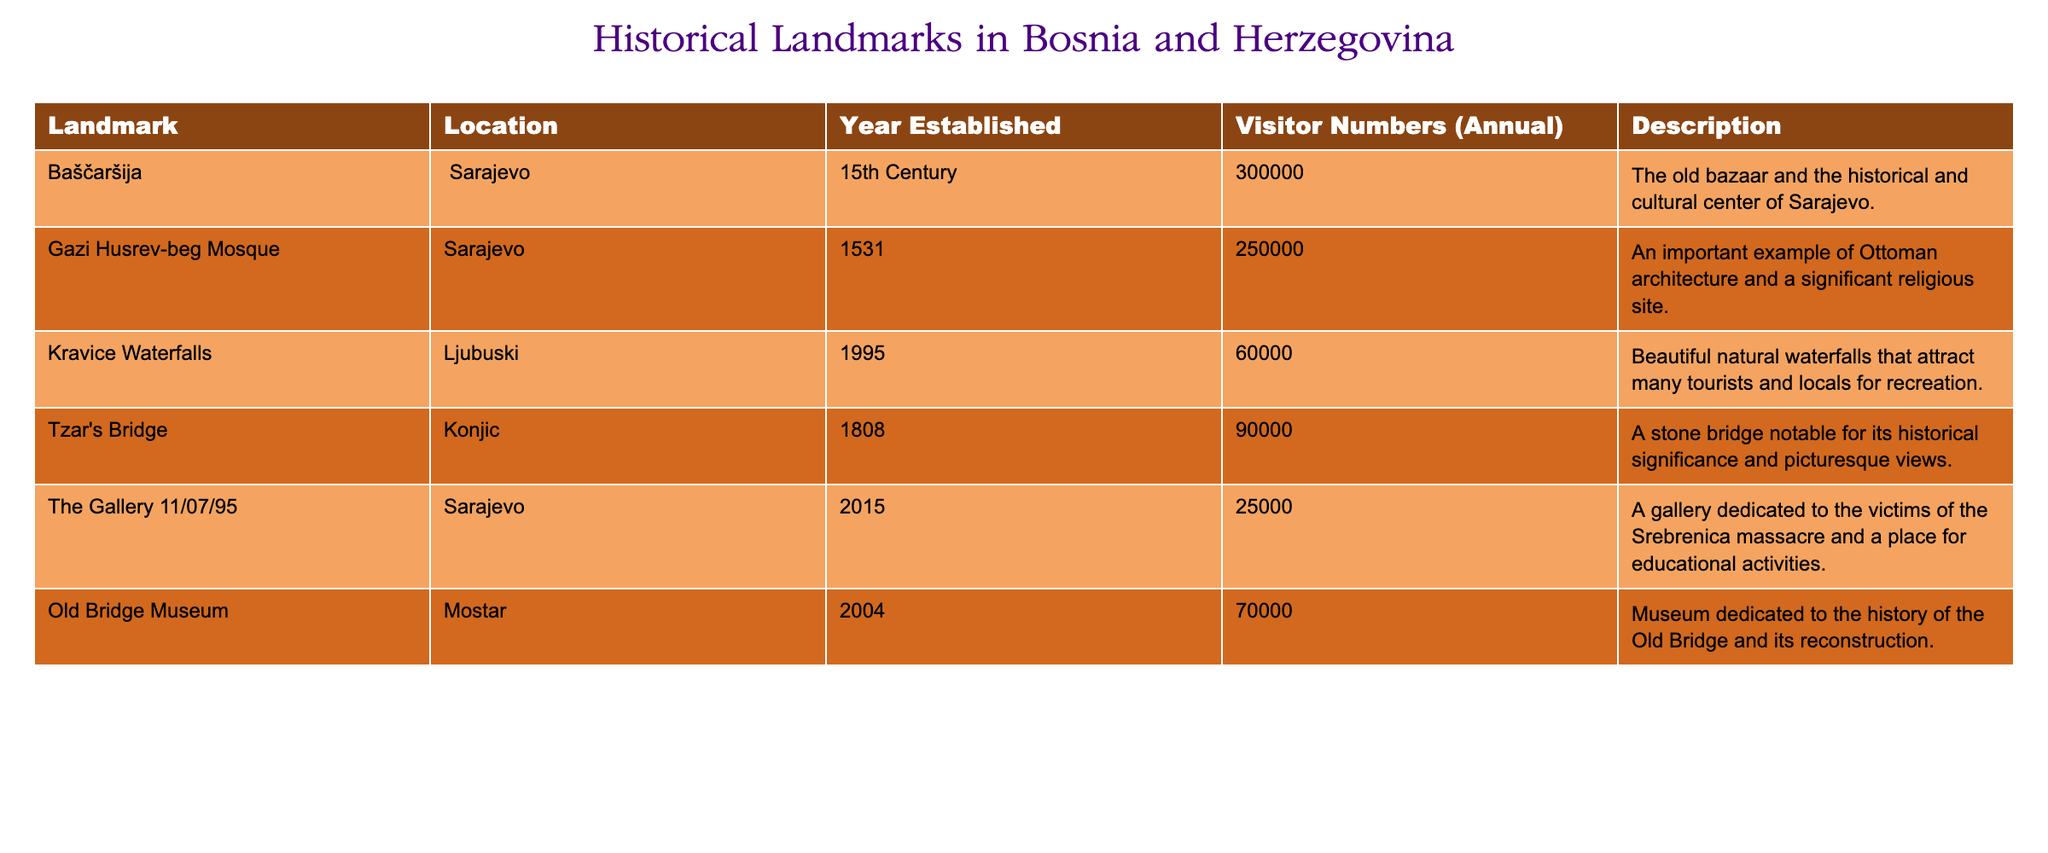What is the visitor number for Baščaršija? The table lists the visitor numbers for Baščaršija as 300000 annually.
Answer: 300000 Which landmark was established in the 15th century? Baščaršija is the only landmark mentioned under the "Year Established" column for the 15th Century.
Answer: Baščaršija What is the total number of visitors for Gazi Husrev-beg Mosque and Kravice Waterfalls combined? The visitor numbers for Gazi Husrev-beg Mosque is 250000 and for Kravice Waterfalls is 60000. Adding them gives 250000 + 60000 = 310000.
Answer: 310000 Is the Old Bridge Museum located in Sarajevo? The table indicates that Old Bridge Museum is located in Mostar, not Sarajevo. Therefore, the answer is no.
Answer: No Which landmark has the lowest visitor number? By comparing all the annual visitor numbers listed, The Gallery 11/07/95 has the lowest number at 25000 visitors.
Answer: 25000 What is the average visitor number for all the landmarks listed? To find the average, sum all visitor numbers: 300000 + 250000 + 60000 + 90000 + 25000 + 70000 = 783000. There are 6 landmarks, so the average is 783000 / 6 = 130500.
Answer: 130500 Are there more visitors to the Gazi Husrev-beg Mosque than the Old Bridge Museum? The visitor numbers for Gazi Husrev-beg Mosque is 250000 while for Old Bridge Museum, it is 70000. Since 250000 is greater than 70000, the answer is yes.
Answer: Yes What year was the Tzar's Bridge established? The table states that Tzar's Bridge was established in the year 1808.
Answer: 1808 Which two landmarks have visitor numbers exceeding 100000? The table indicates that Baščaršija (300000) and Gazi Husrev-beg Mosque (250000) are the only landmarks with visitor numbers exceeding 100000.
Answer: Baščaršija and Gazi Husrev-beg Mosque 